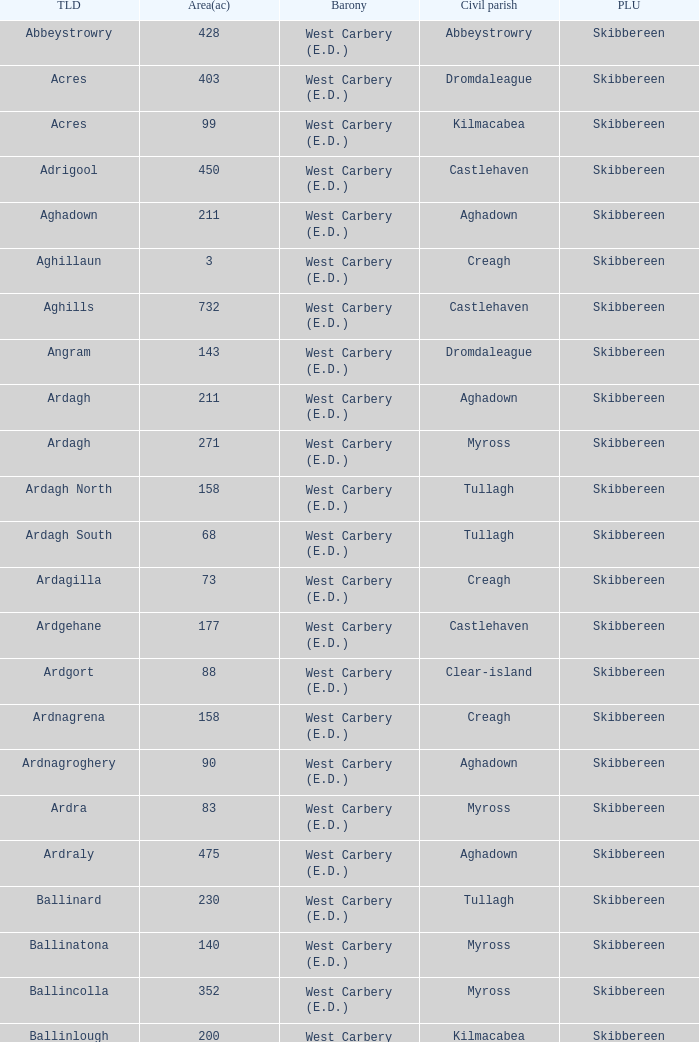What is the greatest area when the Poor Law Union is Skibbereen and the Civil Parish is Tullagh? 796.0. 